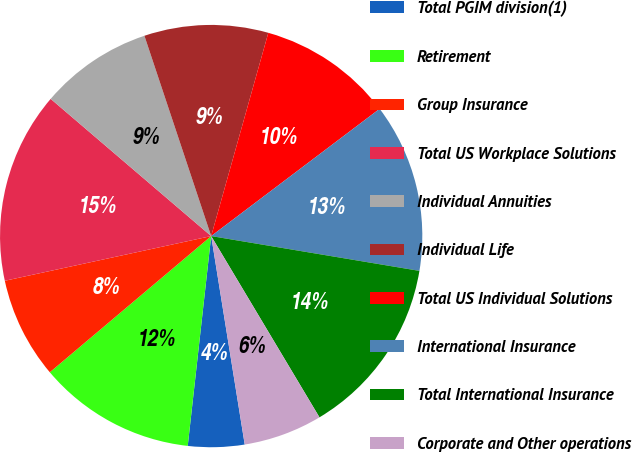Convert chart to OTSL. <chart><loc_0><loc_0><loc_500><loc_500><pie_chart><fcel>Total PGIM division(1)<fcel>Retirement<fcel>Group Insurance<fcel>Total US Workplace Solutions<fcel>Individual Annuities<fcel>Individual Life<fcel>Total US Individual Solutions<fcel>International Insurance<fcel>Total International Insurance<fcel>Corporate and Other operations<nl><fcel>4.31%<fcel>12.07%<fcel>7.76%<fcel>14.65%<fcel>8.62%<fcel>9.48%<fcel>10.34%<fcel>12.93%<fcel>13.79%<fcel>6.03%<nl></chart> 